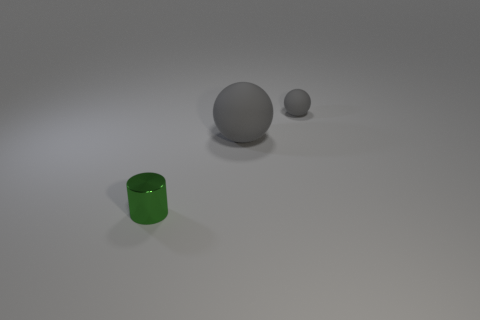What is the material of the green cylinder on the left side of the tiny sphere?
Ensure brevity in your answer.  Metal. There is a big object that is the same material as the tiny gray object; what is its color?
Make the answer very short. Gray. Do the tiny gray matte object and the gray thing in front of the small gray ball have the same shape?
Give a very brief answer. Yes. Are there any small gray balls to the right of the big gray matte object?
Your answer should be compact. Yes. There is a tiny object that is the same color as the big sphere; what is it made of?
Offer a very short reply. Rubber. Is the size of the metal cylinder the same as the gray object that is to the left of the small gray matte sphere?
Make the answer very short. No. Are there any other large rubber things of the same color as the big object?
Give a very brief answer. No. Are there any tiny gray objects that have the same shape as the big object?
Offer a terse response. Yes. There is a thing that is both on the left side of the tiny gray object and to the right of the green metallic object; what is its shape?
Offer a very short reply. Sphere. What number of other small cylinders have the same material as the cylinder?
Provide a short and direct response. 0. 